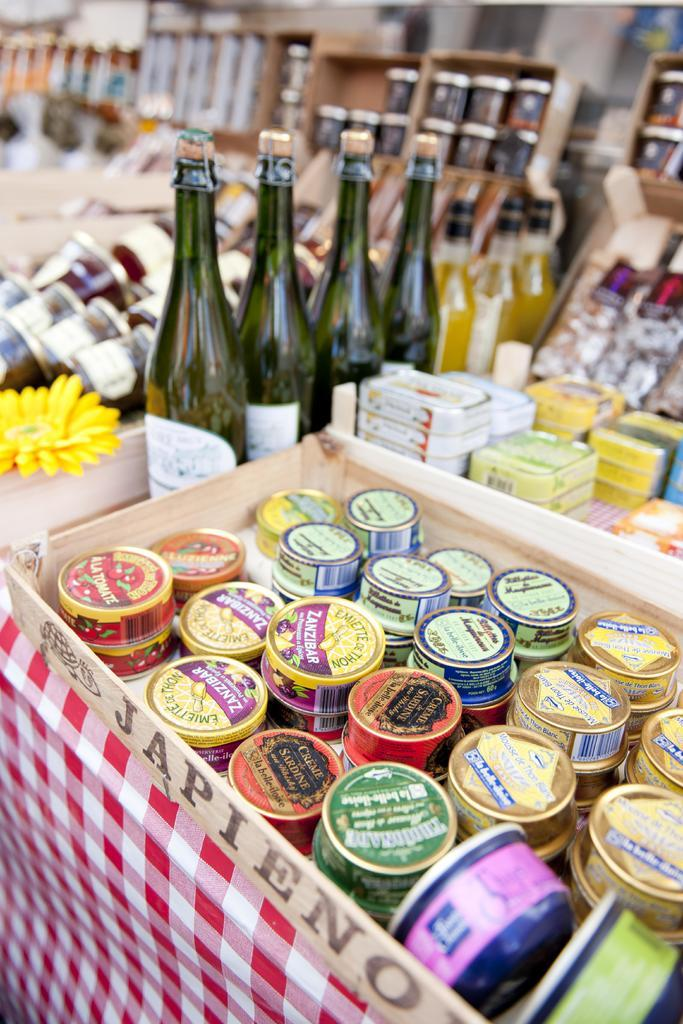<image>
Write a terse but informative summary of the picture. A store display of different types of wines and cheeses like Zanzibar. 